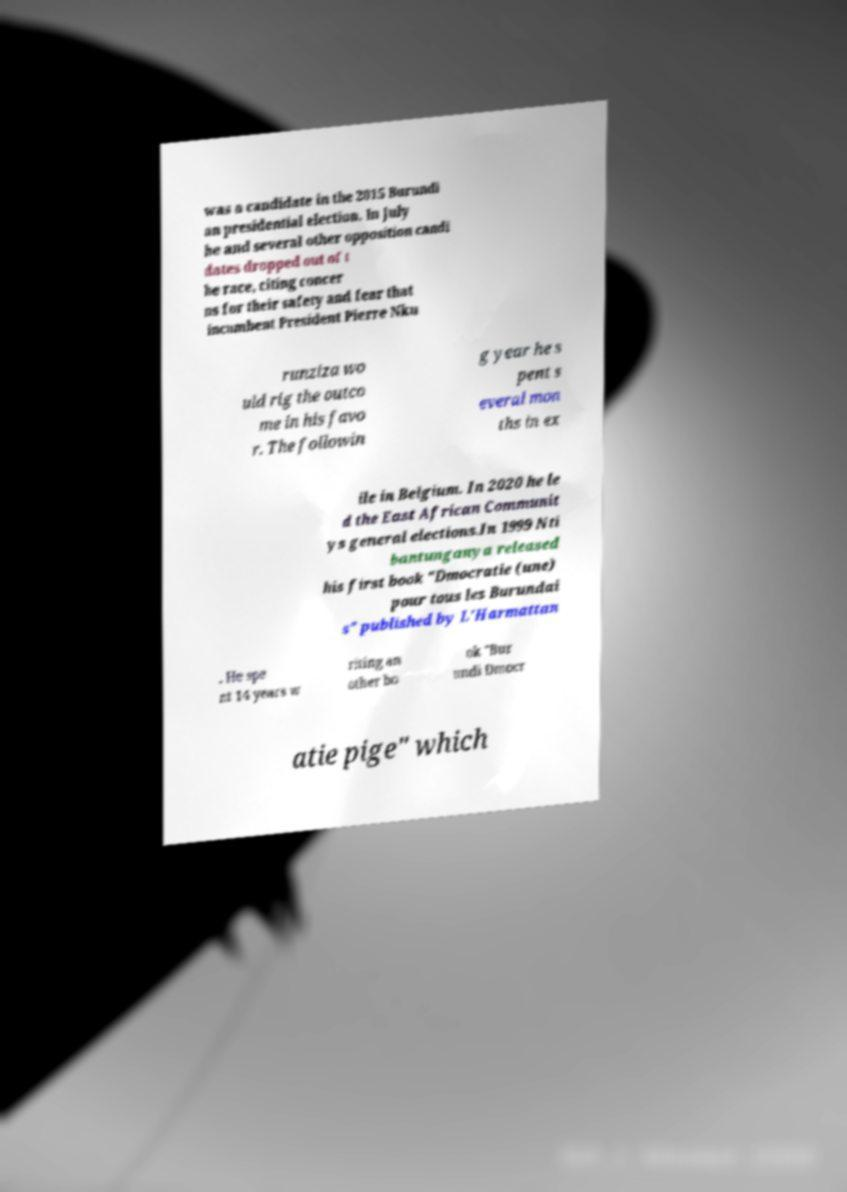Can you accurately transcribe the text from the provided image for me? was a candidate in the 2015 Burundi an presidential election. In July he and several other opposition candi dates dropped out of t he race, citing concer ns for their safety and fear that incumbent President Pierre Nku runziza wo uld rig the outco me in his favo r. The followin g year he s pent s everal mon ths in ex ile in Belgium. In 2020 he le d the East African Communit ys general elections.In 1999 Nti bantunganya released his first book "Dmocratie (une) pour tous les Burundai s" published by L'Harmattan . He spe nt 14 years w riting an other bo ok "Bur undi Dmocr atie pige" which 